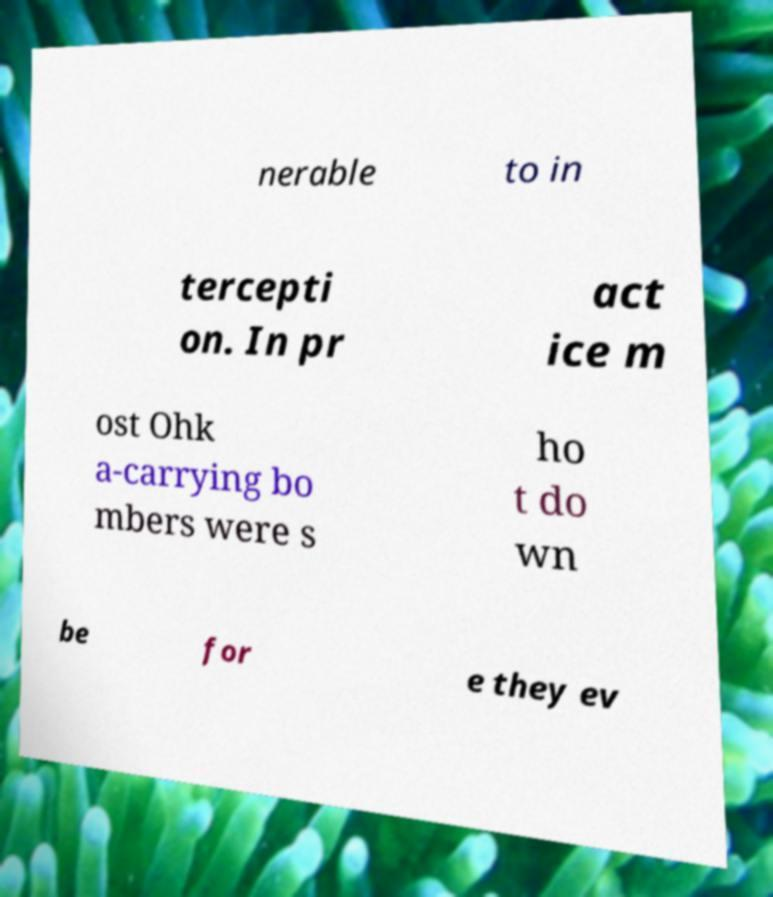Please identify and transcribe the text found in this image. nerable to in tercepti on. In pr act ice m ost Ohk a-carrying bo mbers were s ho t do wn be for e they ev 